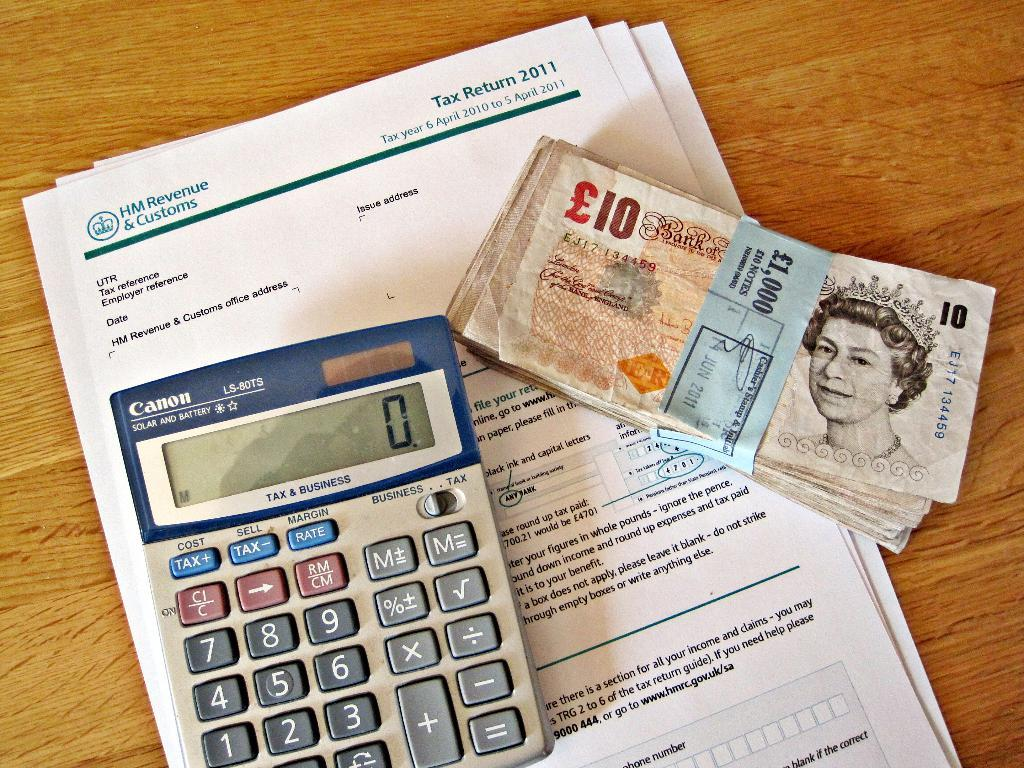<image>
Relay a brief, clear account of the picture shown. A cannon calculator sitting on top of tax return 2011 papers and some british money on the side. 